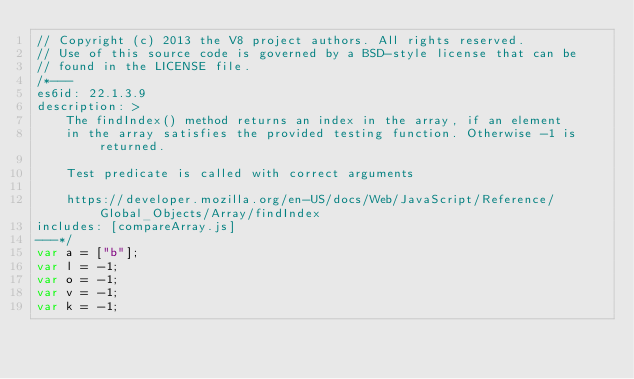Convert code to text. <code><loc_0><loc_0><loc_500><loc_500><_JavaScript_>// Copyright (c) 2013 the V8 project authors. All rights reserved.
// Use of this source code is governed by a BSD-style license that can be
// found in the LICENSE file.
/*---
es6id: 22.1.3.9
description: >
    The findIndex() method returns an index in the array, if an element
    in the array satisfies the provided testing function. Otherwise -1 is returned.

    Test predicate is called with correct arguments

    https://developer.mozilla.org/en-US/docs/Web/JavaScript/Reference/Global_Objects/Array/findIndex
includes: [compareArray.js]
---*/
var a = ["b"];
var l = -1;
var o = -1;
var v = -1;
var k = -1;
</code> 